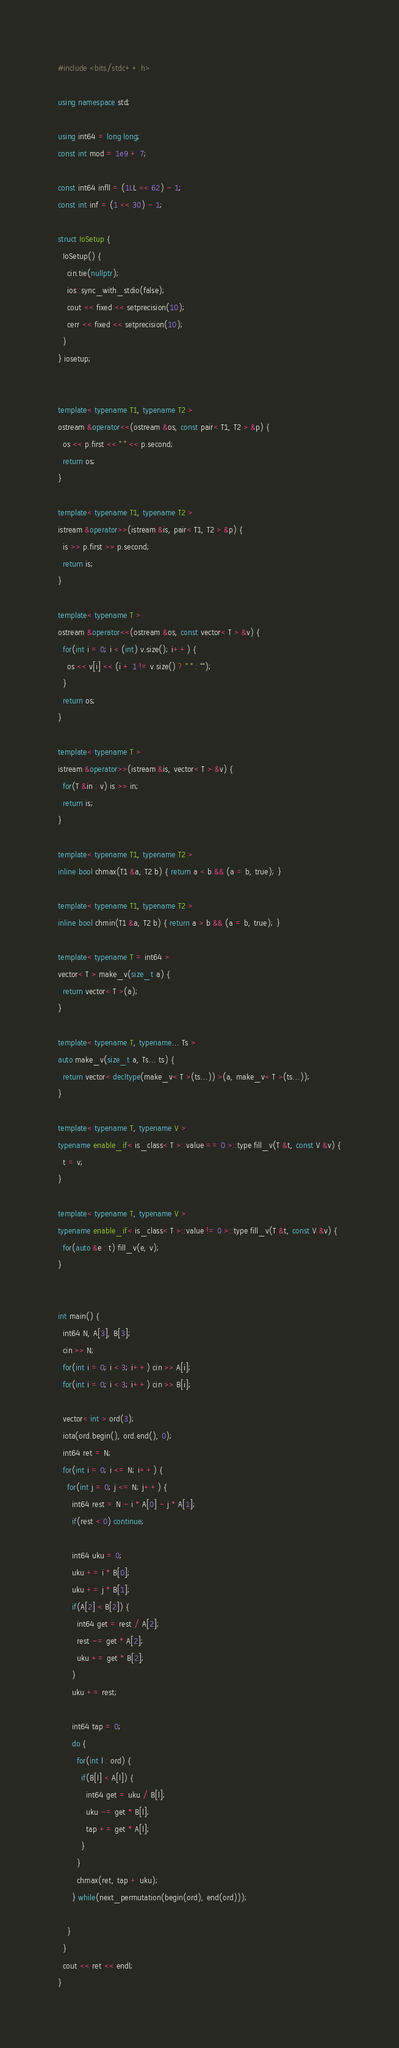Convert code to text. <code><loc_0><loc_0><loc_500><loc_500><_C++_>#include <bits/stdc++.h>

using namespace std;

using int64 = long long;
const int mod = 1e9 + 7;

const int64 infll = (1LL << 62) - 1;
const int inf = (1 << 30) - 1;

struct IoSetup {
  IoSetup() {
    cin.tie(nullptr);
    ios::sync_with_stdio(false);
    cout << fixed << setprecision(10);
    cerr << fixed << setprecision(10);
  }
} iosetup;


template< typename T1, typename T2 >
ostream &operator<<(ostream &os, const pair< T1, T2 > &p) {
  os << p.first << " " << p.second;
  return os;
}

template< typename T1, typename T2 >
istream &operator>>(istream &is, pair< T1, T2 > &p) {
  is >> p.first >> p.second;
  return is;
}

template< typename T >
ostream &operator<<(ostream &os, const vector< T > &v) {
  for(int i = 0; i < (int) v.size(); i++) {
    os << v[i] << (i + 1 != v.size() ? " " : "");
  }
  return os;
}

template< typename T >
istream &operator>>(istream &is, vector< T > &v) {
  for(T &in : v) is >> in;
  return is;
}

template< typename T1, typename T2 >
inline bool chmax(T1 &a, T2 b) { return a < b && (a = b, true); }

template< typename T1, typename T2 >
inline bool chmin(T1 &a, T2 b) { return a > b && (a = b, true); }

template< typename T = int64 >
vector< T > make_v(size_t a) {
  return vector< T >(a);
}

template< typename T, typename... Ts >
auto make_v(size_t a, Ts... ts) {
  return vector< decltype(make_v< T >(ts...)) >(a, make_v< T >(ts...));
}

template< typename T, typename V >
typename enable_if< is_class< T >::value == 0 >::type fill_v(T &t, const V &v) {
  t = v;
}

template< typename T, typename V >
typename enable_if< is_class< T >::value != 0 >::type fill_v(T &t, const V &v) {
  for(auto &e : t) fill_v(e, v);
}


int main() {
  int64 N, A[3], B[3];
  cin >> N;
  for(int i = 0; i < 3; i++) cin >> A[i];
  for(int i = 0; i < 3; i++) cin >> B[i];

  vector< int > ord(3);
  iota(ord.begin(), ord.end(), 0);
  int64 ret = N;
  for(int i = 0; i <= N; i++) {
    for(int j = 0; j <= N; j++) {
      int64 rest = N - i * A[0] - j * A[1];
      if(rest < 0) continue;

      int64 uku = 0;
      uku += i * B[0];
      uku += j * B[1];
      if(A[2] < B[2]) {
        int64 get = rest / A[2];
        rest -= get * A[2];
        uku += get * B[2];
      }
      uku += rest;

      int64 tap = 0;
      do {
        for(int l : ord) {
          if(B[l] < A[l]) {
            int64 get = uku / B[l];
            uku -= get * B[l];
            tap += get * A[l];
          }
        }
        chmax(ret, tap + uku);
      } while(next_permutation(begin(ord), end(ord)));

    }
  }
  cout << ret << endl;
}


</code> 